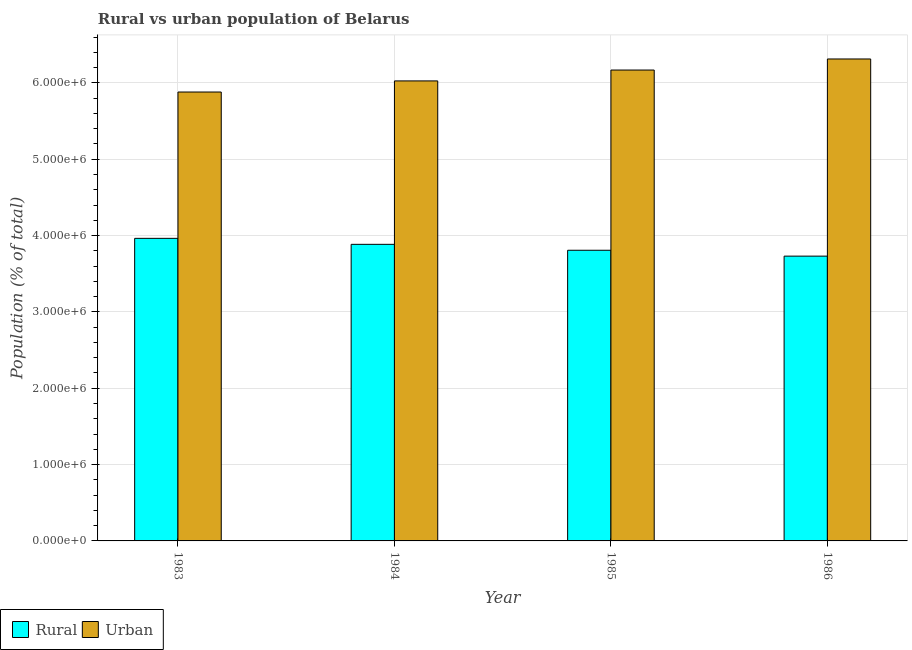How many different coloured bars are there?
Your response must be concise. 2. How many groups of bars are there?
Your answer should be very brief. 4. What is the label of the 1st group of bars from the left?
Your answer should be compact. 1983. In how many cases, is the number of bars for a given year not equal to the number of legend labels?
Provide a short and direct response. 0. What is the rural population density in 1984?
Your answer should be very brief. 3.88e+06. Across all years, what is the maximum urban population density?
Provide a succinct answer. 6.31e+06. Across all years, what is the minimum rural population density?
Ensure brevity in your answer.  3.73e+06. In which year was the urban population density maximum?
Make the answer very short. 1986. What is the total urban population density in the graph?
Offer a terse response. 2.44e+07. What is the difference between the urban population density in 1983 and that in 1985?
Provide a short and direct response. -2.88e+05. What is the difference between the rural population density in 1985 and the urban population density in 1984?
Give a very brief answer. -7.76e+04. What is the average urban population density per year?
Provide a short and direct response. 6.10e+06. In the year 1986, what is the difference between the rural population density and urban population density?
Ensure brevity in your answer.  0. What is the ratio of the urban population density in 1985 to that in 1986?
Offer a terse response. 0.98. Is the urban population density in 1983 less than that in 1986?
Provide a succinct answer. Yes. Is the difference between the rural population density in 1983 and 1985 greater than the difference between the urban population density in 1983 and 1985?
Provide a succinct answer. No. What is the difference between the highest and the second highest urban population density?
Make the answer very short. 1.45e+05. What is the difference between the highest and the lowest urban population density?
Your answer should be compact. 4.33e+05. What does the 2nd bar from the left in 1984 represents?
Your answer should be compact. Urban. What does the 1st bar from the right in 1986 represents?
Offer a terse response. Urban. How many bars are there?
Provide a succinct answer. 8. Are all the bars in the graph horizontal?
Your answer should be very brief. No. How many years are there in the graph?
Give a very brief answer. 4. What is the difference between two consecutive major ticks on the Y-axis?
Ensure brevity in your answer.  1.00e+06. Does the graph contain any zero values?
Give a very brief answer. No. Does the graph contain grids?
Offer a terse response. Yes. How are the legend labels stacked?
Provide a short and direct response. Horizontal. What is the title of the graph?
Ensure brevity in your answer.  Rural vs urban population of Belarus. What is the label or title of the X-axis?
Your answer should be very brief. Year. What is the label or title of the Y-axis?
Make the answer very short. Population (% of total). What is the Population (% of total) of Rural in 1983?
Provide a short and direct response. 3.96e+06. What is the Population (% of total) in Urban in 1983?
Provide a short and direct response. 5.88e+06. What is the Population (% of total) of Rural in 1984?
Your response must be concise. 3.88e+06. What is the Population (% of total) of Urban in 1984?
Give a very brief answer. 6.03e+06. What is the Population (% of total) of Rural in 1985?
Keep it short and to the point. 3.81e+06. What is the Population (% of total) of Urban in 1985?
Give a very brief answer. 6.17e+06. What is the Population (% of total) of Rural in 1986?
Make the answer very short. 3.73e+06. What is the Population (% of total) of Urban in 1986?
Your response must be concise. 6.31e+06. Across all years, what is the maximum Population (% of total) in Rural?
Make the answer very short. 3.96e+06. Across all years, what is the maximum Population (% of total) in Urban?
Offer a very short reply. 6.31e+06. Across all years, what is the minimum Population (% of total) of Rural?
Offer a terse response. 3.73e+06. Across all years, what is the minimum Population (% of total) in Urban?
Your response must be concise. 5.88e+06. What is the total Population (% of total) of Rural in the graph?
Offer a very short reply. 1.54e+07. What is the total Population (% of total) of Urban in the graph?
Offer a very short reply. 2.44e+07. What is the difference between the Population (% of total) of Rural in 1983 and that in 1984?
Your answer should be compact. 7.85e+04. What is the difference between the Population (% of total) of Urban in 1983 and that in 1984?
Your answer should be compact. -1.45e+05. What is the difference between the Population (% of total) in Rural in 1983 and that in 1985?
Your response must be concise. 1.56e+05. What is the difference between the Population (% of total) in Urban in 1983 and that in 1985?
Provide a succinct answer. -2.88e+05. What is the difference between the Population (% of total) in Rural in 1983 and that in 1986?
Keep it short and to the point. 2.33e+05. What is the difference between the Population (% of total) in Urban in 1983 and that in 1986?
Ensure brevity in your answer.  -4.33e+05. What is the difference between the Population (% of total) of Rural in 1984 and that in 1985?
Your answer should be very brief. 7.76e+04. What is the difference between the Population (% of total) of Urban in 1984 and that in 1985?
Your answer should be compact. -1.43e+05. What is the difference between the Population (% of total) in Rural in 1984 and that in 1986?
Provide a short and direct response. 1.54e+05. What is the difference between the Population (% of total) of Urban in 1984 and that in 1986?
Offer a terse response. -2.87e+05. What is the difference between the Population (% of total) in Rural in 1985 and that in 1986?
Your answer should be very brief. 7.69e+04. What is the difference between the Population (% of total) of Urban in 1985 and that in 1986?
Keep it short and to the point. -1.45e+05. What is the difference between the Population (% of total) of Rural in 1983 and the Population (% of total) of Urban in 1984?
Your answer should be compact. -2.06e+06. What is the difference between the Population (% of total) of Rural in 1983 and the Population (% of total) of Urban in 1985?
Keep it short and to the point. -2.20e+06. What is the difference between the Population (% of total) in Rural in 1983 and the Population (% of total) in Urban in 1986?
Provide a succinct answer. -2.35e+06. What is the difference between the Population (% of total) in Rural in 1984 and the Population (% of total) in Urban in 1985?
Your response must be concise. -2.28e+06. What is the difference between the Population (% of total) in Rural in 1984 and the Population (% of total) in Urban in 1986?
Give a very brief answer. -2.43e+06. What is the difference between the Population (% of total) in Rural in 1985 and the Population (% of total) in Urban in 1986?
Keep it short and to the point. -2.51e+06. What is the average Population (% of total) in Rural per year?
Ensure brevity in your answer.  3.85e+06. What is the average Population (% of total) in Urban per year?
Ensure brevity in your answer.  6.10e+06. In the year 1983, what is the difference between the Population (% of total) in Rural and Population (% of total) in Urban?
Provide a succinct answer. -1.92e+06. In the year 1984, what is the difference between the Population (% of total) of Rural and Population (% of total) of Urban?
Offer a terse response. -2.14e+06. In the year 1985, what is the difference between the Population (% of total) in Rural and Population (% of total) in Urban?
Your answer should be compact. -2.36e+06. In the year 1986, what is the difference between the Population (% of total) in Rural and Population (% of total) in Urban?
Make the answer very short. -2.58e+06. What is the ratio of the Population (% of total) of Rural in 1983 to that in 1984?
Give a very brief answer. 1.02. What is the ratio of the Population (% of total) in Urban in 1983 to that in 1984?
Provide a short and direct response. 0.98. What is the ratio of the Population (% of total) of Rural in 1983 to that in 1985?
Offer a terse response. 1.04. What is the ratio of the Population (% of total) in Urban in 1983 to that in 1985?
Make the answer very short. 0.95. What is the ratio of the Population (% of total) of Rural in 1983 to that in 1986?
Make the answer very short. 1.06. What is the ratio of the Population (% of total) of Urban in 1983 to that in 1986?
Give a very brief answer. 0.93. What is the ratio of the Population (% of total) of Rural in 1984 to that in 1985?
Provide a short and direct response. 1.02. What is the ratio of the Population (% of total) in Urban in 1984 to that in 1985?
Your answer should be very brief. 0.98. What is the ratio of the Population (% of total) in Rural in 1984 to that in 1986?
Your answer should be compact. 1.04. What is the ratio of the Population (% of total) of Urban in 1984 to that in 1986?
Offer a very short reply. 0.95. What is the ratio of the Population (% of total) of Rural in 1985 to that in 1986?
Provide a succinct answer. 1.02. What is the ratio of the Population (% of total) in Urban in 1985 to that in 1986?
Provide a short and direct response. 0.98. What is the difference between the highest and the second highest Population (% of total) in Rural?
Offer a terse response. 7.85e+04. What is the difference between the highest and the second highest Population (% of total) of Urban?
Provide a short and direct response. 1.45e+05. What is the difference between the highest and the lowest Population (% of total) in Rural?
Provide a succinct answer. 2.33e+05. What is the difference between the highest and the lowest Population (% of total) in Urban?
Your answer should be very brief. 4.33e+05. 